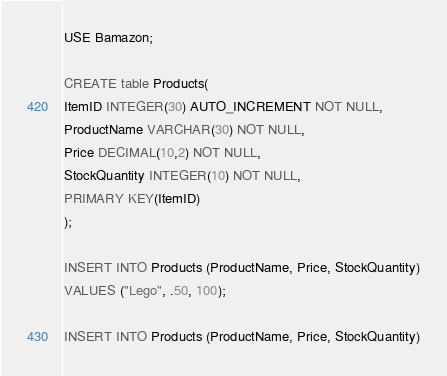Convert code to text. <code><loc_0><loc_0><loc_500><loc_500><_SQL_>
USE Bamazon;

CREATE table Products(
ItemID INTEGER(30) AUTO_INCREMENT NOT NULL,
ProductName VARCHAR(30) NOT NULL,
Price DECIMAL(10,2) NOT NULL,
StockQuantity INTEGER(10) NOT NULL,
PRIMARY KEY(ItemID)
);

INSERT INTO Products (ProductName, Price, StockQuantity)
VALUES ("Lego", .50, 100);

INSERT INTO Products (ProductName, Price, StockQuantity)</code> 